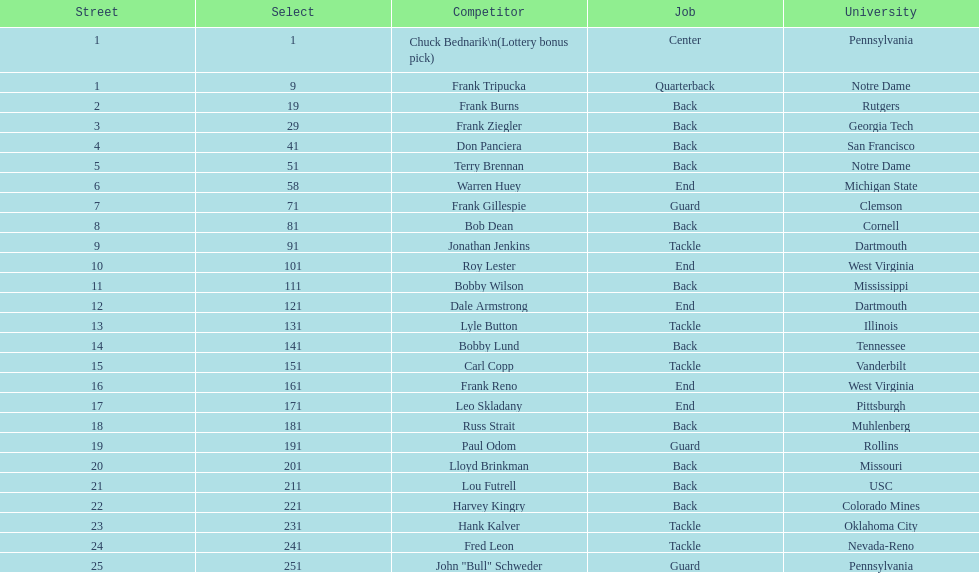How many draft picks were between frank tripucka and dale armstrong? 10. 